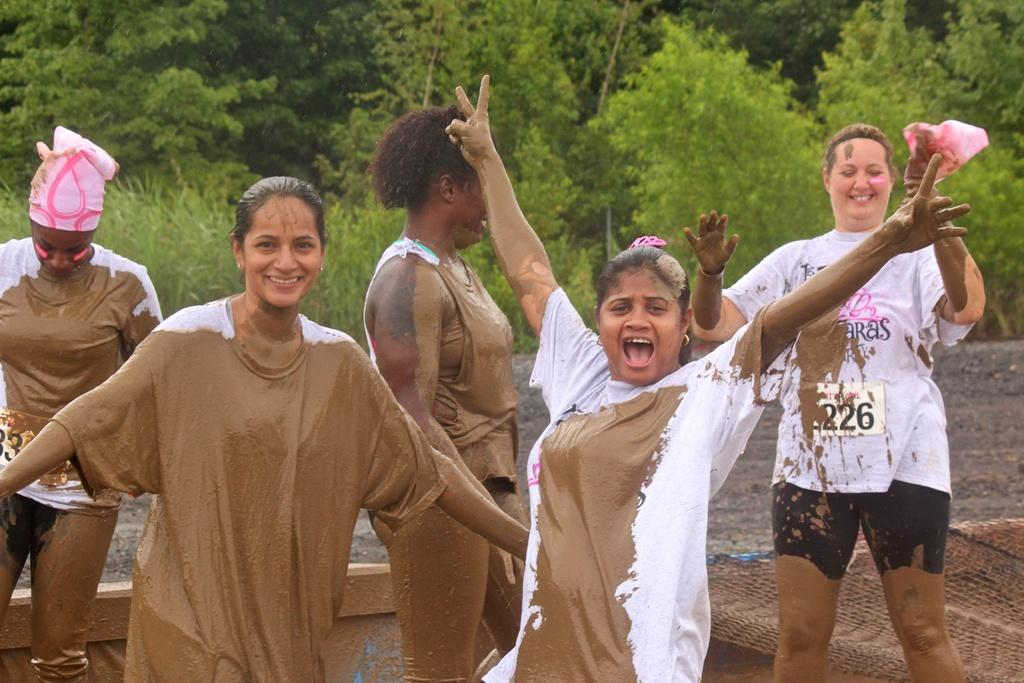What is the main subject of the image? The main subject of the image is a group of people. What are the people in the image doing? The people are standing. What colors are the shirts of the people in the image? The people are wearing white and brown color shirts. What can be seen in the background of the image? There are trees in the background of the image. What is the color of the trees in the image? The trees are green in color. What type of bat can be seen flying in the image? There is no bat present in the image; it features a group of people standing with trees in the background. What is the quince used for in the image? There is no quince present in the image. 